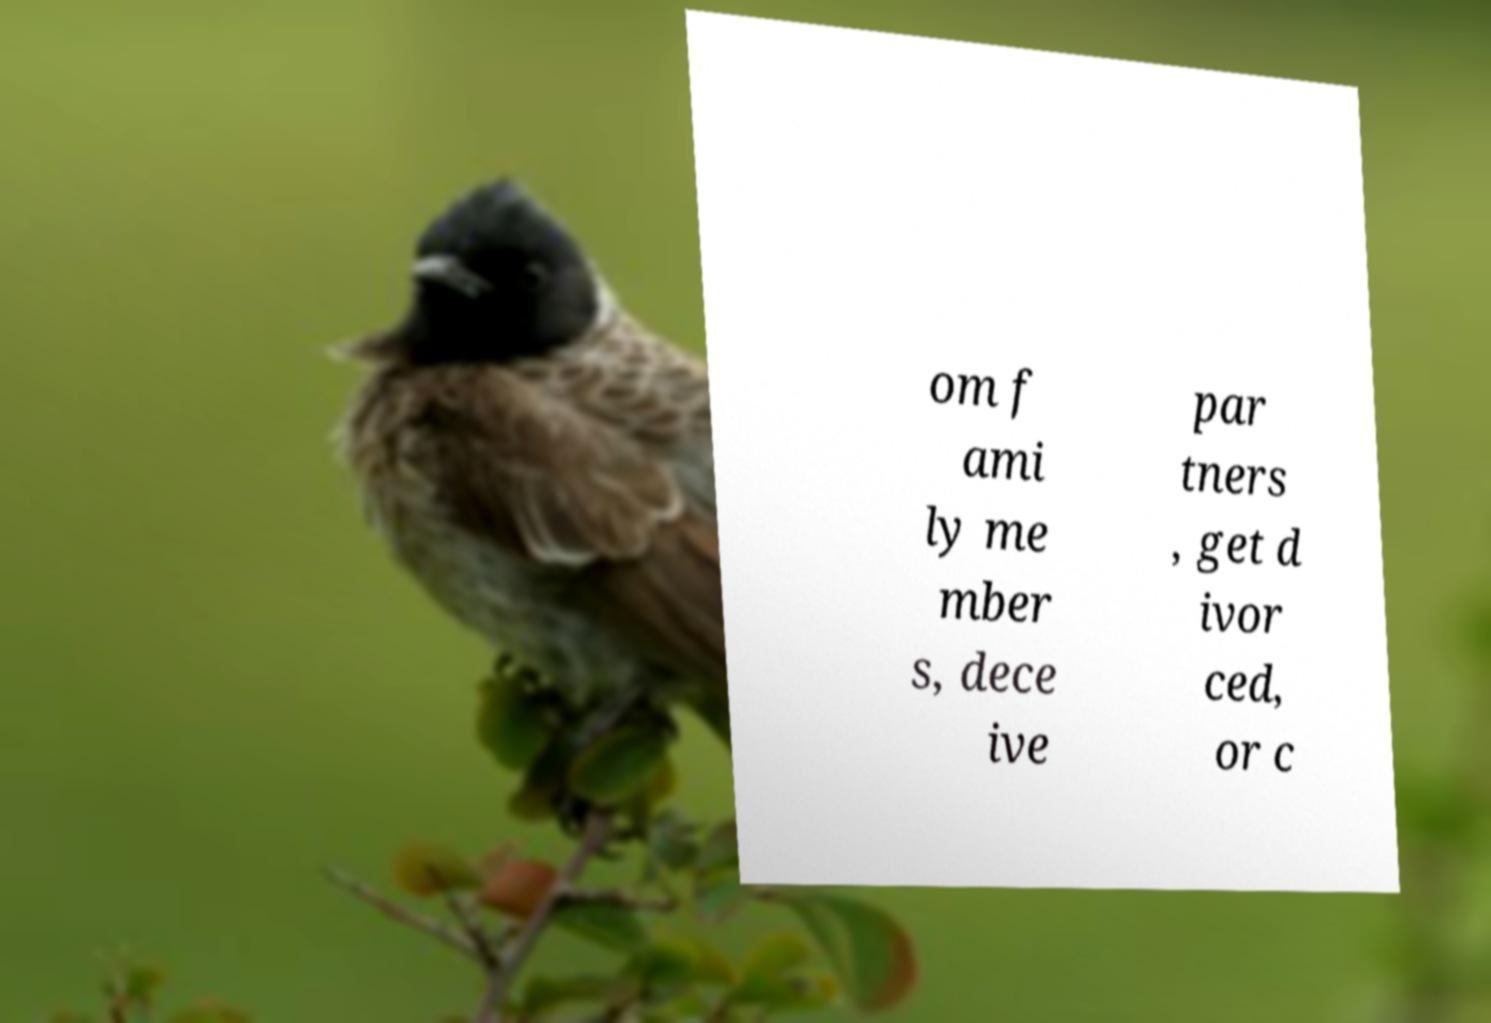Please identify and transcribe the text found in this image. om f ami ly me mber s, dece ive par tners , get d ivor ced, or c 